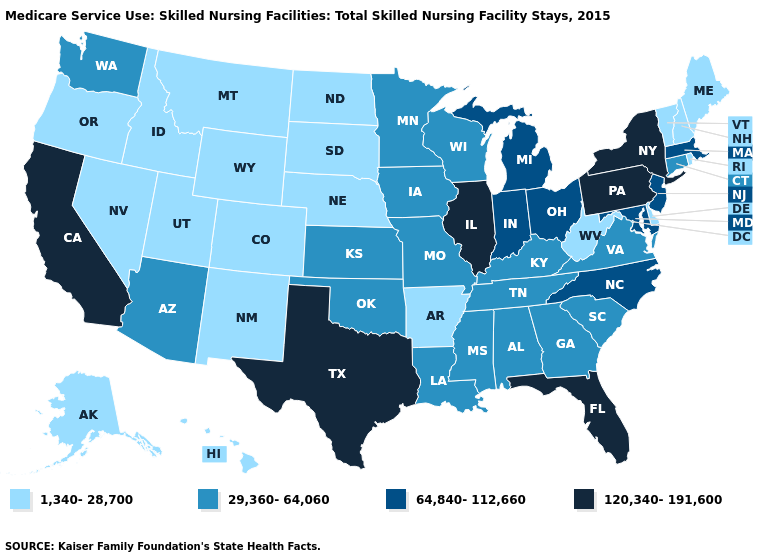Does West Virginia have a higher value than Kansas?
Be succinct. No. Name the states that have a value in the range 1,340-28,700?
Quick response, please. Alaska, Arkansas, Colorado, Delaware, Hawaii, Idaho, Maine, Montana, Nebraska, Nevada, New Hampshire, New Mexico, North Dakota, Oregon, Rhode Island, South Dakota, Utah, Vermont, West Virginia, Wyoming. Name the states that have a value in the range 29,360-64,060?
Be succinct. Alabama, Arizona, Connecticut, Georgia, Iowa, Kansas, Kentucky, Louisiana, Minnesota, Mississippi, Missouri, Oklahoma, South Carolina, Tennessee, Virginia, Washington, Wisconsin. Among the states that border Maine , which have the lowest value?
Keep it brief. New Hampshire. What is the value of Hawaii?
Short answer required. 1,340-28,700. Among the states that border Louisiana , does Arkansas have the lowest value?
Answer briefly. Yes. What is the value of South Dakota?
Be succinct. 1,340-28,700. Among the states that border Missouri , which have the highest value?
Keep it brief. Illinois. Does the map have missing data?
Concise answer only. No. Does Indiana have the same value as New Jersey?
Be succinct. Yes. Does Texas have the highest value in the USA?
Keep it brief. Yes. Is the legend a continuous bar?
Answer briefly. No. Does the first symbol in the legend represent the smallest category?
Short answer required. Yes. Does Alaska have a lower value than South Dakota?
Give a very brief answer. No. Is the legend a continuous bar?
Be succinct. No. 